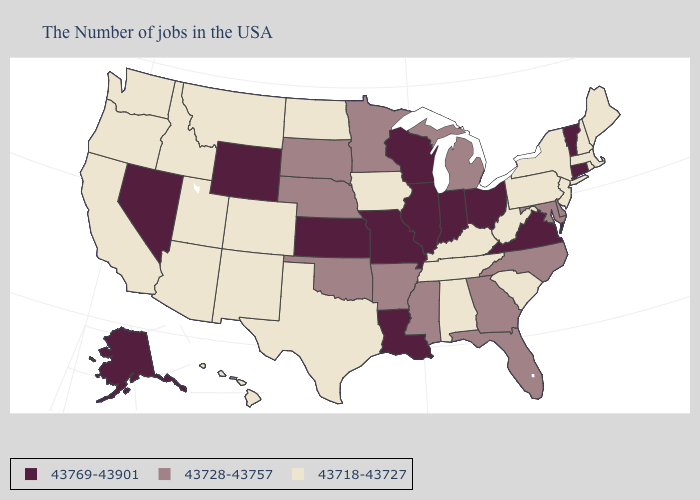Name the states that have a value in the range 43718-43727?
Quick response, please. Maine, Massachusetts, Rhode Island, New Hampshire, New York, New Jersey, Pennsylvania, South Carolina, West Virginia, Kentucky, Alabama, Tennessee, Iowa, Texas, North Dakota, Colorado, New Mexico, Utah, Montana, Arizona, Idaho, California, Washington, Oregon, Hawaii. Name the states that have a value in the range 43728-43757?
Answer briefly. Delaware, Maryland, North Carolina, Florida, Georgia, Michigan, Mississippi, Arkansas, Minnesota, Nebraska, Oklahoma, South Dakota. Name the states that have a value in the range 43728-43757?
Short answer required. Delaware, Maryland, North Carolina, Florida, Georgia, Michigan, Mississippi, Arkansas, Minnesota, Nebraska, Oklahoma, South Dakota. Is the legend a continuous bar?
Be succinct. No. Name the states that have a value in the range 43769-43901?
Give a very brief answer. Vermont, Connecticut, Virginia, Ohio, Indiana, Wisconsin, Illinois, Louisiana, Missouri, Kansas, Wyoming, Nevada, Alaska. Which states hav the highest value in the West?
Quick response, please. Wyoming, Nevada, Alaska. Is the legend a continuous bar?
Concise answer only. No. Does the map have missing data?
Keep it brief. No. Name the states that have a value in the range 43718-43727?
Keep it brief. Maine, Massachusetts, Rhode Island, New Hampshire, New York, New Jersey, Pennsylvania, South Carolina, West Virginia, Kentucky, Alabama, Tennessee, Iowa, Texas, North Dakota, Colorado, New Mexico, Utah, Montana, Arizona, Idaho, California, Washington, Oregon, Hawaii. Does the map have missing data?
Give a very brief answer. No. Which states hav the highest value in the Northeast?
Concise answer only. Vermont, Connecticut. Name the states that have a value in the range 43728-43757?
Keep it brief. Delaware, Maryland, North Carolina, Florida, Georgia, Michigan, Mississippi, Arkansas, Minnesota, Nebraska, Oklahoma, South Dakota. Does Connecticut have the lowest value in the USA?
Quick response, please. No. Name the states that have a value in the range 43718-43727?
Quick response, please. Maine, Massachusetts, Rhode Island, New Hampshire, New York, New Jersey, Pennsylvania, South Carolina, West Virginia, Kentucky, Alabama, Tennessee, Iowa, Texas, North Dakota, Colorado, New Mexico, Utah, Montana, Arizona, Idaho, California, Washington, Oregon, Hawaii. Name the states that have a value in the range 43769-43901?
Write a very short answer. Vermont, Connecticut, Virginia, Ohio, Indiana, Wisconsin, Illinois, Louisiana, Missouri, Kansas, Wyoming, Nevada, Alaska. 